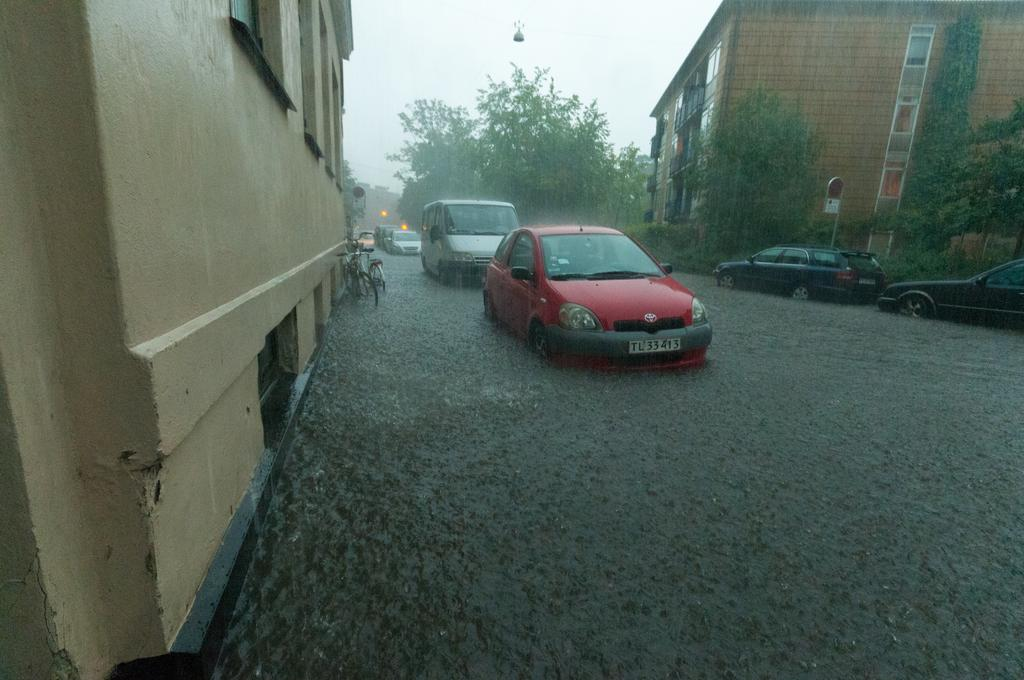What is the weather condition in the image? The image is captured during rain. What can be seen on the road in the image? There are vehicles on the road in the image. What structures are visible in the image? There are buildings visible in the image. What type of vegetation can be seen in the image? There are trees visible in the image. What color is the orange hanging from the tree in the image? There is no orange present in the image; it only shows rain, vehicles, buildings, and trees. 